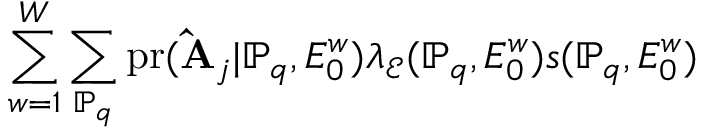Convert formula to latex. <formula><loc_0><loc_0><loc_500><loc_500>\sum _ { w = 1 } ^ { W } \sum _ { \mathbb { P } _ { q } } p r ( \hat { A } _ { j } | \mathbb { P } _ { q } , E _ { 0 } ^ { w } ) \lambda _ { \mathcal { E } } ( \mathbb { P } _ { q } , E _ { 0 } ^ { w } ) s ( \mathbb { P } _ { q } , E _ { 0 } ^ { w } )</formula> 